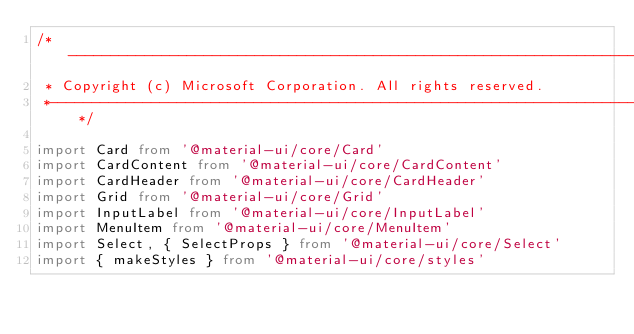Convert code to text. <code><loc_0><loc_0><loc_500><loc_500><_TypeScript_>/*---------------------------------------------------------------------------------------------
 * Copyright (c) Microsoft Corporation. All rights reserved.
 *--------------------------------------------------------------------------------------------*/

import Card from '@material-ui/core/Card'
import CardContent from '@material-ui/core/CardContent'
import CardHeader from '@material-ui/core/CardHeader'
import Grid from '@material-ui/core/Grid'
import InputLabel from '@material-ui/core/InputLabel'
import MenuItem from '@material-ui/core/MenuItem'
import Select, { SelectProps } from '@material-ui/core/Select'
import { makeStyles } from '@material-ui/core/styles'</code> 